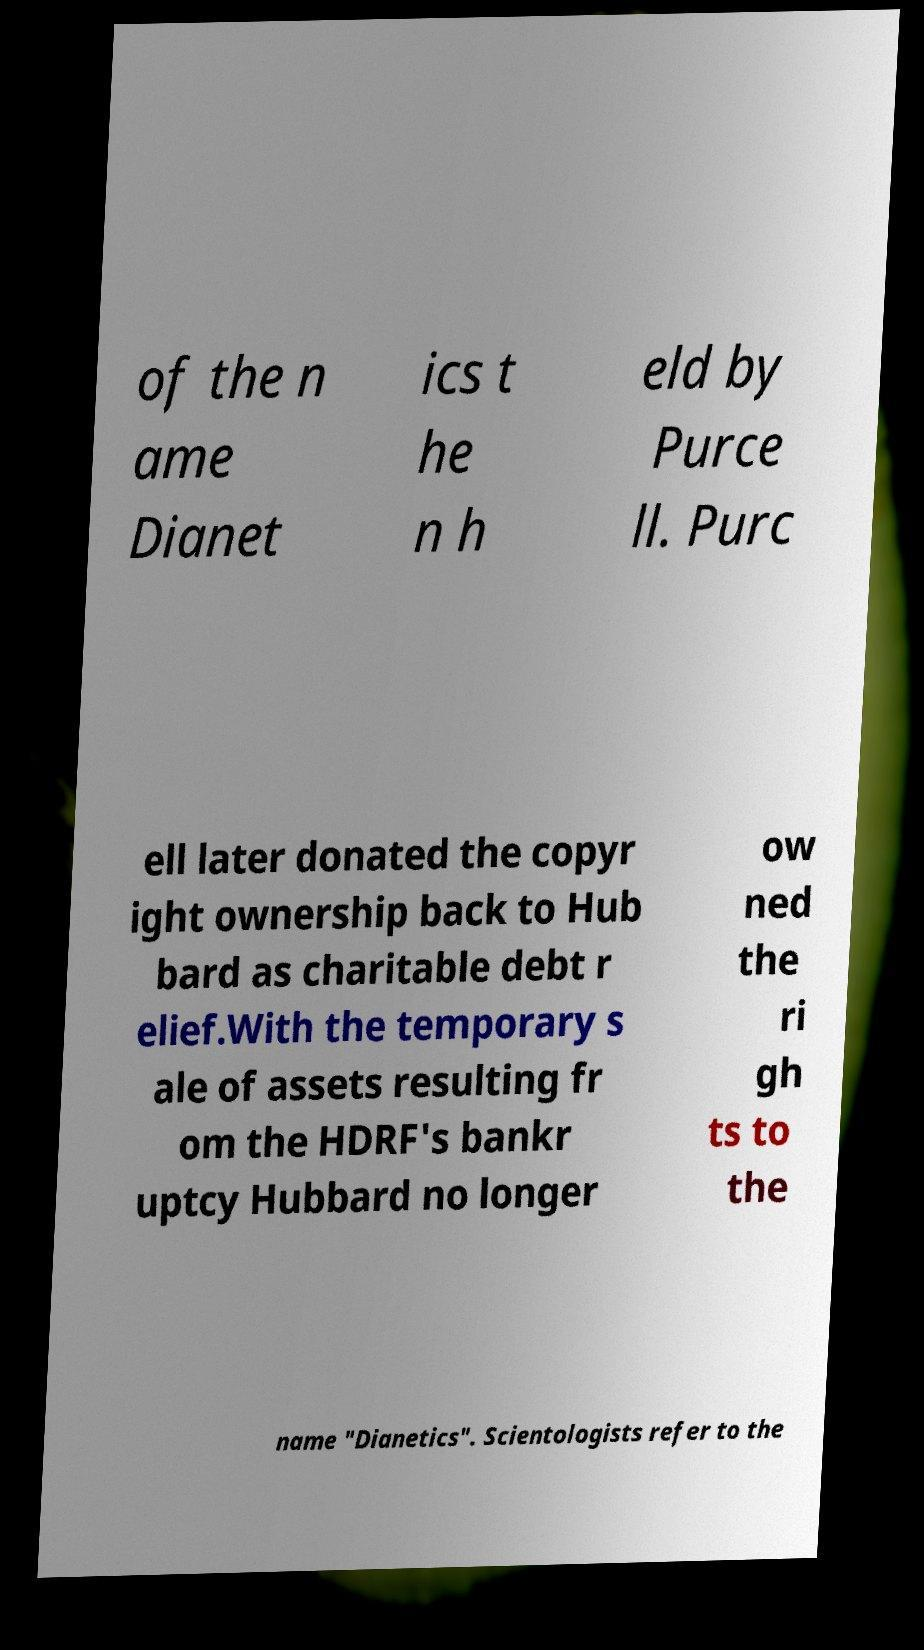I need the written content from this picture converted into text. Can you do that? of the n ame Dianet ics t he n h eld by Purce ll. Purc ell later donated the copyr ight ownership back to Hub bard as charitable debt r elief.With the temporary s ale of assets resulting fr om the HDRF's bankr uptcy Hubbard no longer ow ned the ri gh ts to the name "Dianetics". Scientologists refer to the 